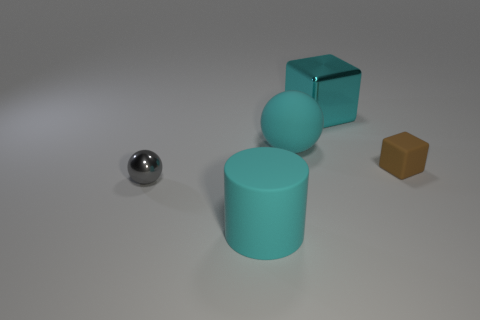Add 5 shiny objects. How many objects exist? 10 Subtract all cylinders. How many objects are left? 4 Subtract all brown things. Subtract all large cyan rubber cylinders. How many objects are left? 3 Add 4 big matte things. How many big matte things are left? 6 Add 2 large cyan shiny things. How many large cyan shiny things exist? 3 Subtract 0 red cubes. How many objects are left? 5 